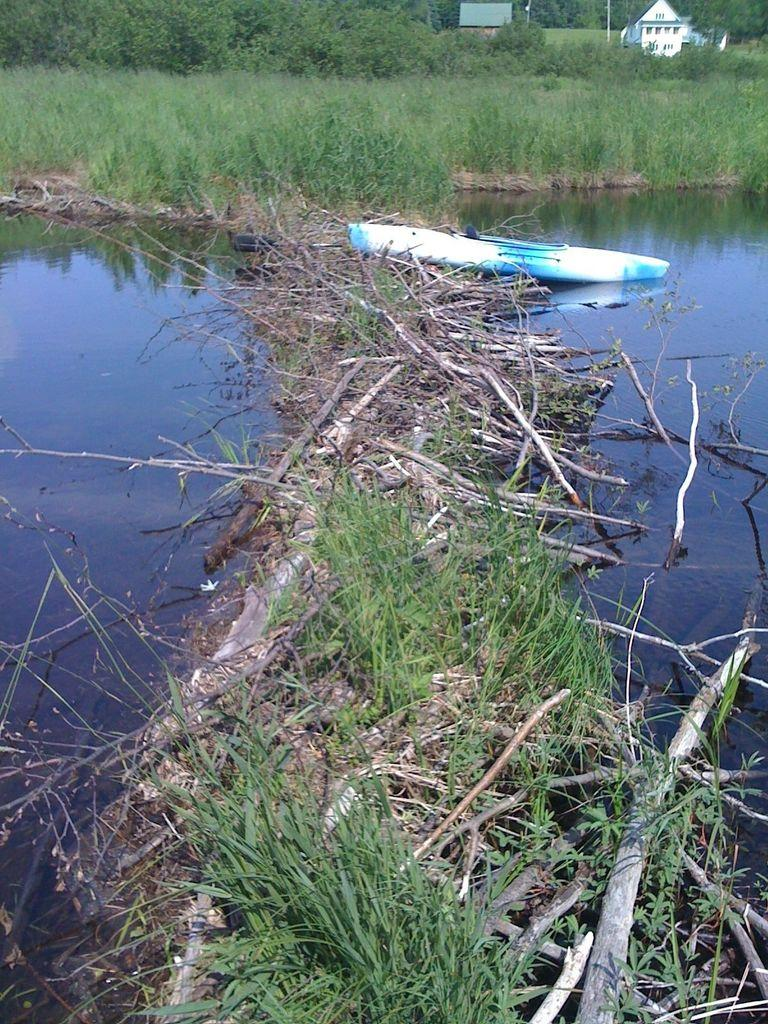What is the primary element visible in the image? There is water in the image. What type of vegetation can be seen in the image? There is grass in the image. What object is present in the water? There is a boat in the image. What can be seen in the distance in the image? There are trees and buildings in the background of the image. What type of letter is being delivered by the boat in the image? There is no letter or indication of a delivery in the image; it simply features a boat in the water. What is the boat using to collect water in the image? There is no pail or water collection device present in the image. 